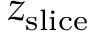Convert formula to latex. <formula><loc_0><loc_0><loc_500><loc_500>z _ { s l i c e }</formula> 